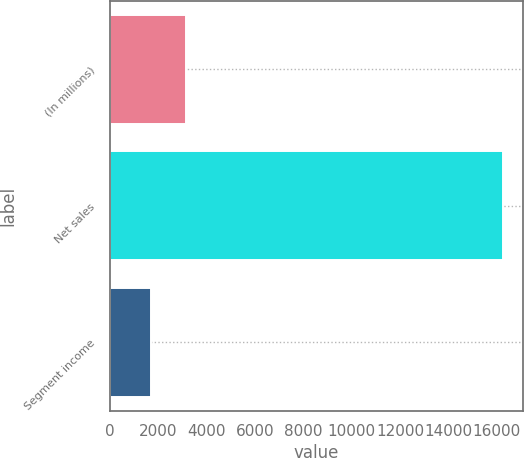<chart> <loc_0><loc_0><loc_500><loc_500><bar_chart><fcel>(In millions)<fcel>Net sales<fcel>Segment income<nl><fcel>3145.01<fcel>16285.1<fcel>1685<nl></chart> 